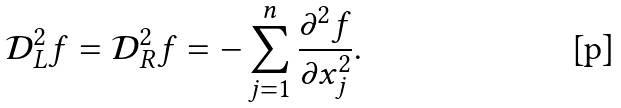<formula> <loc_0><loc_0><loc_500><loc_500>\mathcal { D } _ { L } ^ { 2 } f = \mathcal { D } _ { R } ^ { 2 } f = - \sum _ { j = 1 } ^ { n } \frac { \partial ^ { 2 } f } { \partial x _ { j } ^ { 2 } } .</formula> 